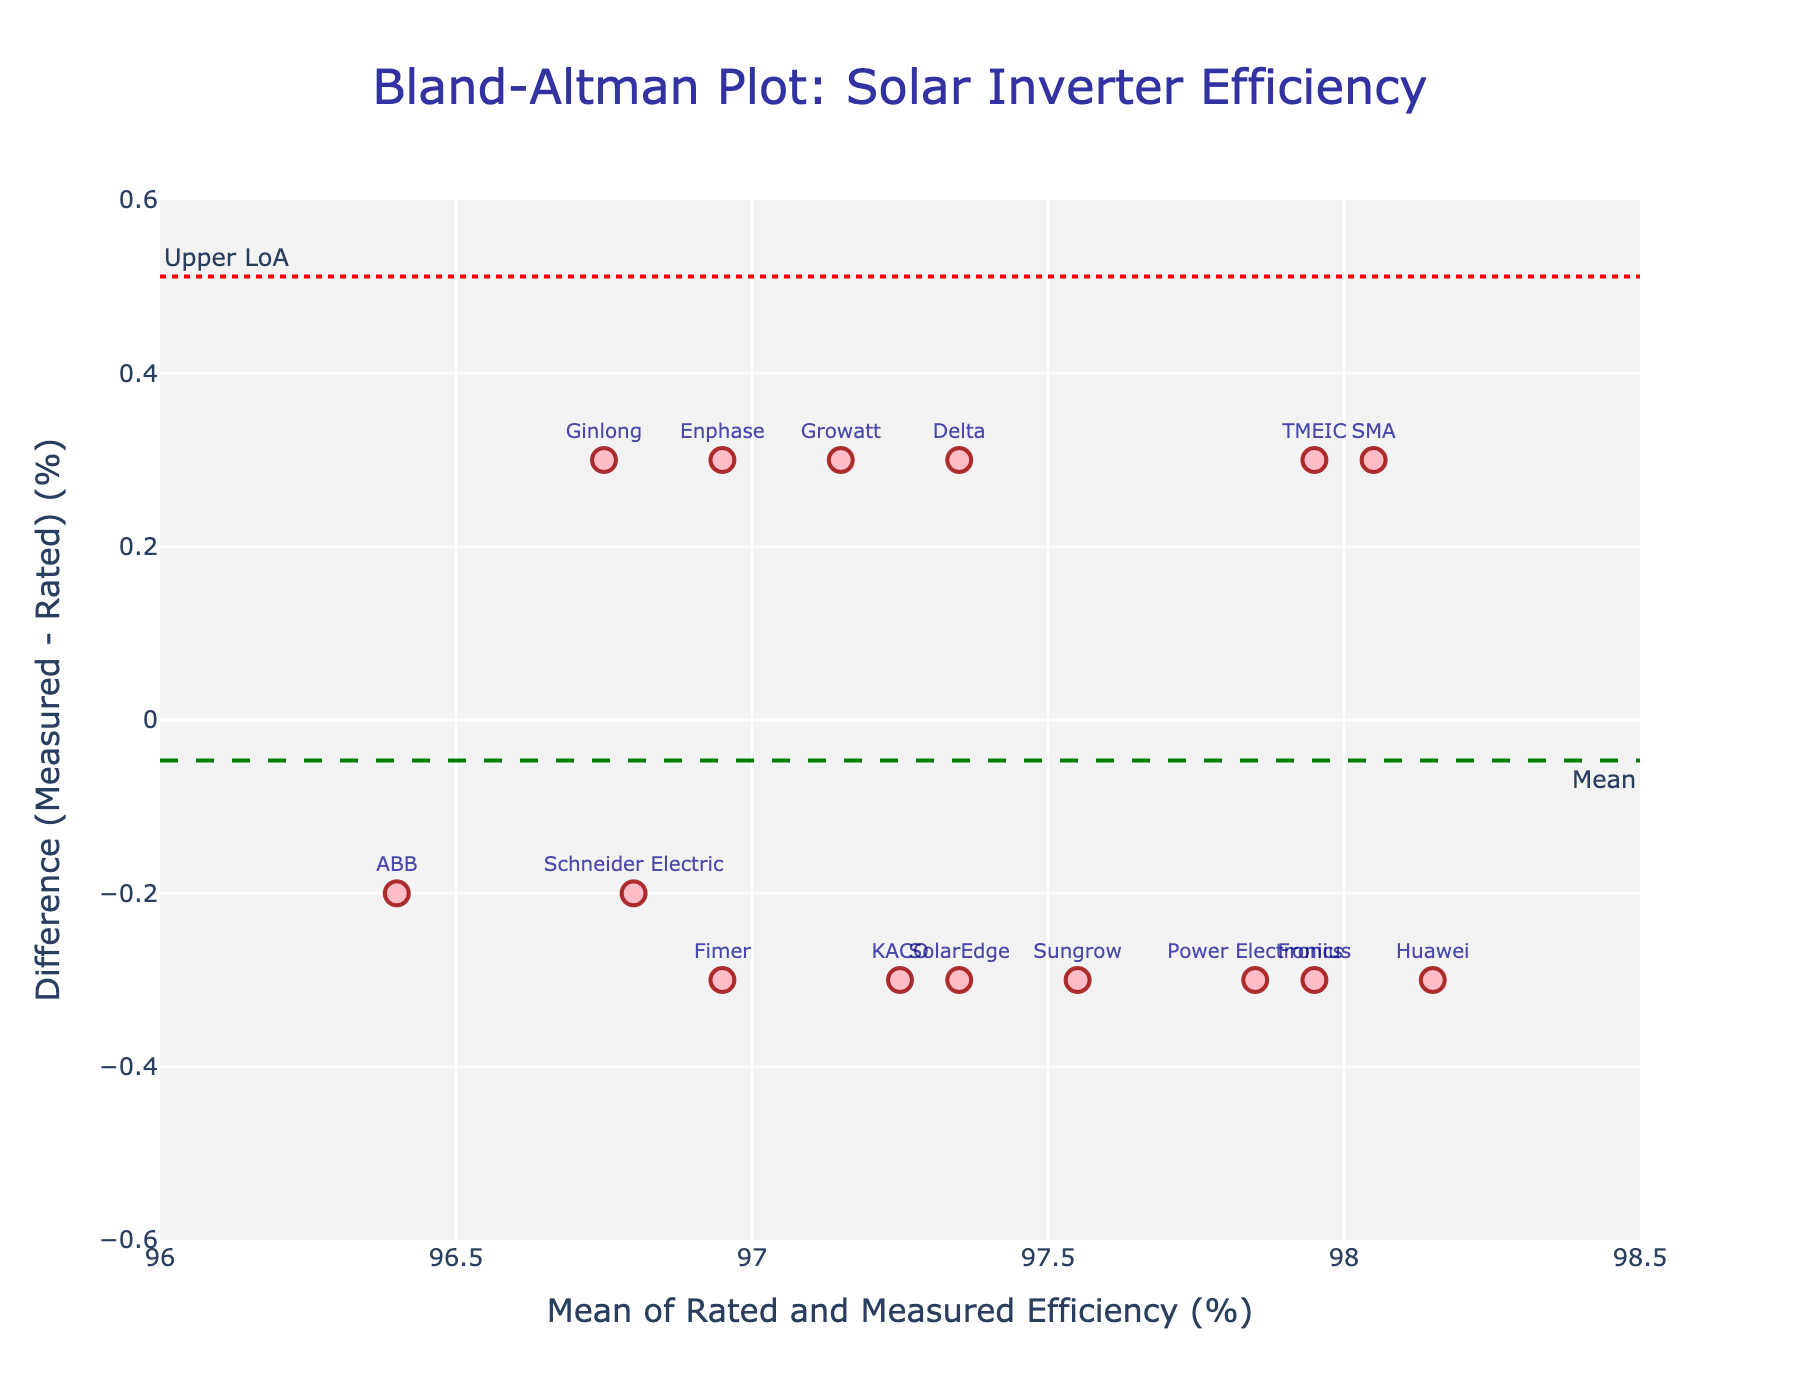What's the title of the plot? The title is located at the top of the plot and is in larger text than other elements, making it easy to identify. The exact wording should be read directly from the plot.
Answer: Bland-Altman Plot: Solar Inverter Efficiency What's represented by the dashed green line? On a Bland–Altman plot, the dashed green line typically represents the mean difference between the two sets of measurements.
Answer: Mean difference What does the dotted red line at the top represent? The dotted red lines on a Bland–Altman plot represent the limits of agreement. The top line is the upper limit of agreement or Upper LoA.
Answer: Upper LoA What's the difference between the Measured Efficiency and Rated Efficiency for SMA? To find the difference, subtract the Rated Efficiency from the Measured Efficiency for SMA: 98.2 - 97.9 = 0.3
Answer: 0.3 Which manufacturer has the highest mean efficiency value? To determine the manufacturer with the highest mean efficiency value, calculate the average of the Rated and Measured Efficiency for each manufacturer and identify the highest average. Huawei has the highest mean: (98.3 + 98.0) / 2 = 98.15
Answer: Huawei Are the majority of the efficiency differences positive or negative? Examine the positions of the points relative to the y=0 line. If more points are above this line, the differences are mostly positive; if below, they are mostly negative. In this case, the majority are positive.
Answer: Positive What do points above the mean difference line indicate compared to those below? Points above the mean difference line indicate that the Measured Efficiency is higher than the Rated Efficiency more often for those manufacturers, while points below indicate the opposite.
Answer: Higher Measured Efficiency Calculate the mean efficiency value for Enphase. The mean efficiency value for Enphase is calculated by averaging the Rated and Measured Efficiency: (96.8 + 97.1) / 2 = 96.95
Answer: 96.95 Which manufacturer has the largest difference (in absolute value) between their Measured and Rated Efficiency? To find the manufacturer with the largest absolute difference, compute the absolute difference for each manufacturer and identify the largest. ABB has the largest:
Answer: 0.2 How does the Bland-Altman plot help in evaluating the performance accuracy across different manufacturers? The plot visualizes the agreement between the Rated and Measured Efficiency, showcasing the mean difference and limits of agreement, which helps in identifying any consistent biases or outliers in the measurements.
Answer: It shows agreement patterns 